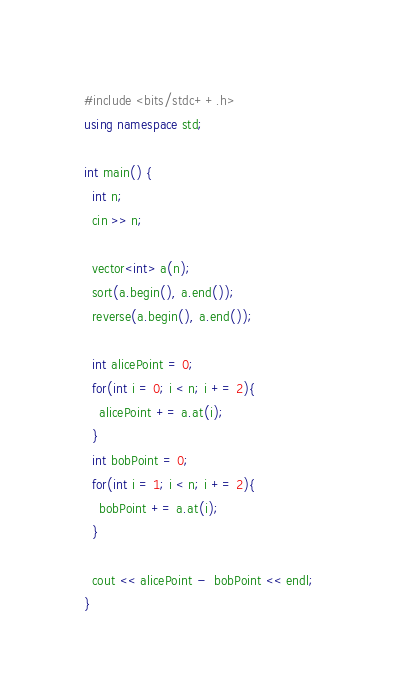Convert code to text. <code><loc_0><loc_0><loc_500><loc_500><_C++_>#include <bits/stdc++.h>
using namespace std;
 
int main() {
  int n;
  cin >> n;
  
  vector<int> a(n);
  sort(a.begin(), a.end());
  reverse(a.begin(), a.end());
  
  int alicePoint = 0;
  for(int i = 0; i < n; i += 2){
    alicePoint += a.at(i);
  }
  int bobPoint = 0;
  for(int i = 1; i < n; i += 2){
    bobPoint += a.at(i);
  }
  
  cout << alicePoint -  bobPoint << endl;
}</code> 